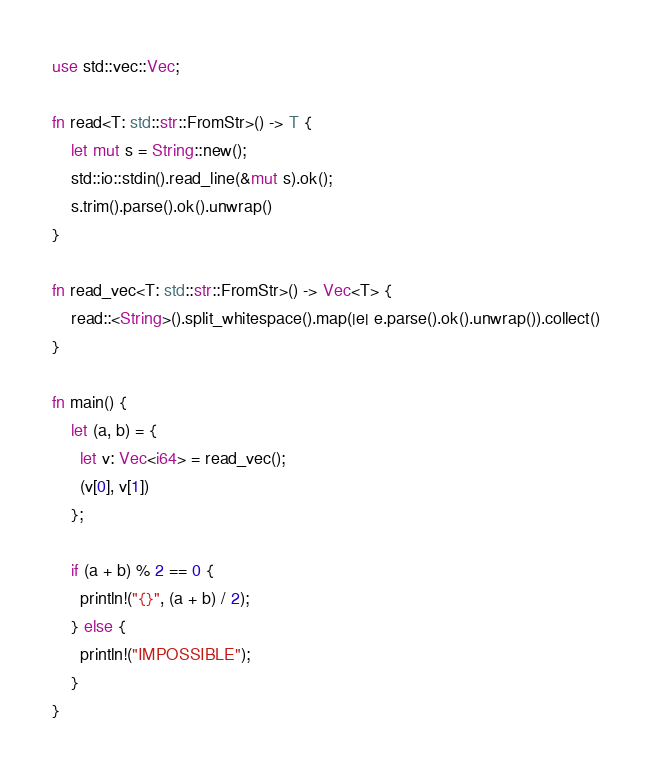<code> <loc_0><loc_0><loc_500><loc_500><_Rust_>use std::vec::Vec;

fn read<T: std::str::FromStr>() -> T {
    let mut s = String::new();
    std::io::stdin().read_line(&mut s).ok();
    s.trim().parse().ok().unwrap()
}

fn read_vec<T: std::str::FromStr>() -> Vec<T> {
    read::<String>().split_whitespace().map(|e| e.parse().ok().unwrap()).collect()
}

fn main() {
    let (a, b) = {
      let v: Vec<i64> = read_vec();
      (v[0], v[1])
    };

    if (a + b) % 2 == 0 {
      println!("{}", (a + b) / 2);
    } else {
      println!("IMPOSSIBLE");
    }
}
</code> 